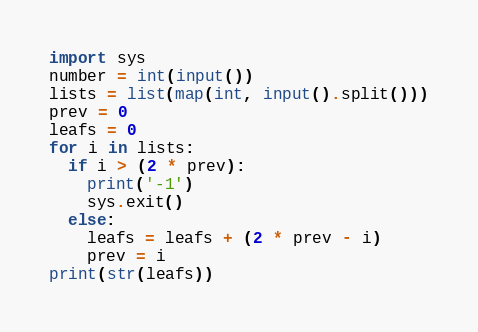Convert code to text. <code><loc_0><loc_0><loc_500><loc_500><_Python_>import sys
number = int(input())
lists = list(map(int, input().split()))
prev = 0
leafs = 0
for i in lists:
  if i > (2 * prev):
    print('-1')
    sys.exit()
  else:
    leafs = leafs + (2 * prev - i)
    prev = i
print(str(leafs))</code> 